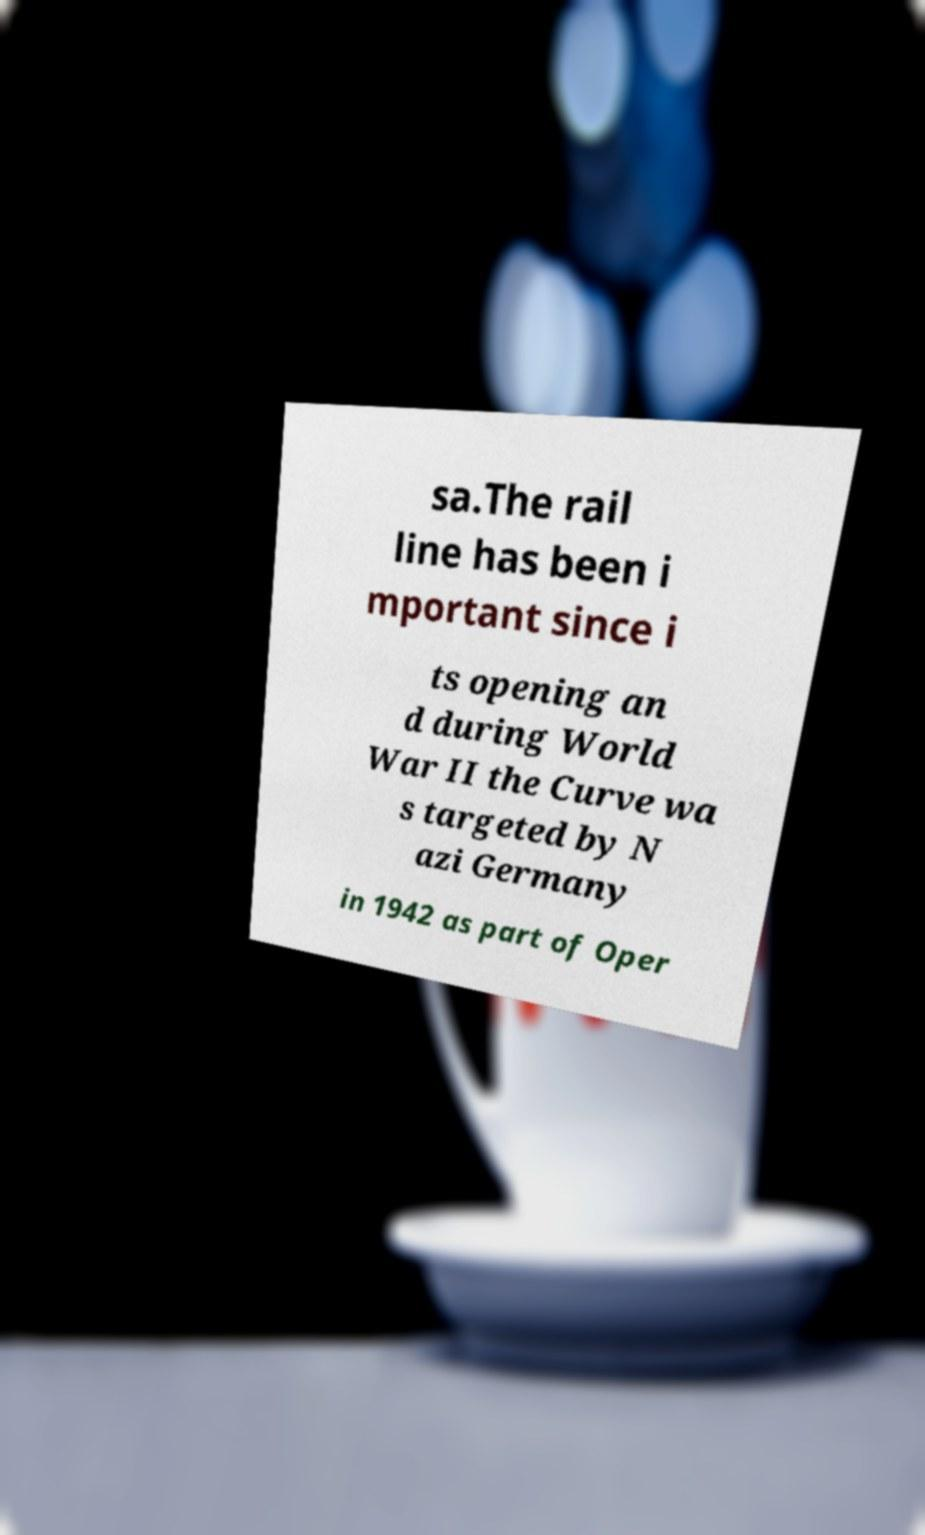For documentation purposes, I need the text within this image transcribed. Could you provide that? sa.The rail line has been i mportant since i ts opening an d during World War II the Curve wa s targeted by N azi Germany in 1942 as part of Oper 